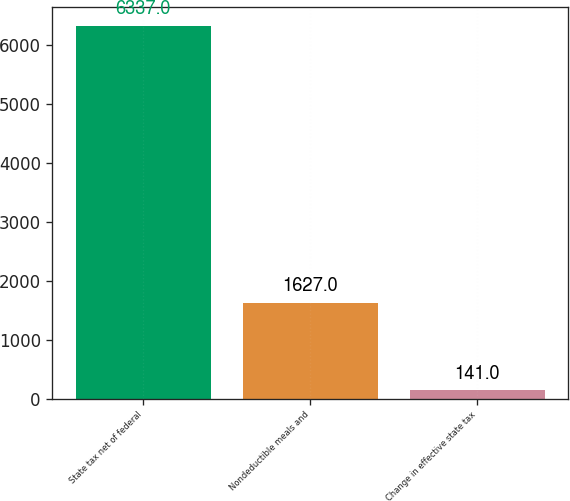<chart> <loc_0><loc_0><loc_500><loc_500><bar_chart><fcel>State tax net of federal<fcel>Nondeductible meals and<fcel>Change in effective state tax<nl><fcel>6337<fcel>1627<fcel>141<nl></chart> 